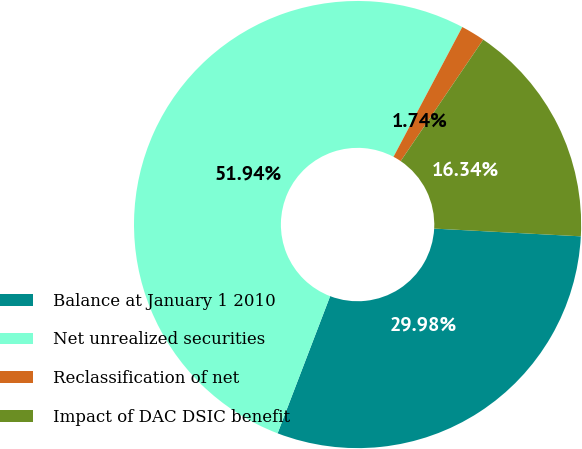Convert chart. <chart><loc_0><loc_0><loc_500><loc_500><pie_chart><fcel>Balance at January 1 2010<fcel>Net unrealized securities<fcel>Reclassification of net<fcel>Impact of DAC DSIC benefit<nl><fcel>29.98%<fcel>51.93%<fcel>1.74%<fcel>16.34%<nl></chart> 